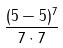<formula> <loc_0><loc_0><loc_500><loc_500>\frac { ( 5 - 5 ) ^ { 7 } } { 7 \cdot 7 }</formula> 